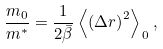Convert formula to latex. <formula><loc_0><loc_0><loc_500><loc_500>\frac { m _ { 0 } } { m ^ { * } } = \frac { 1 } { 2 \bar { \beta } } \left \langle \left ( \Delta { r } \right ) ^ { 2 } \right \rangle _ { \, 0 } ,</formula> 